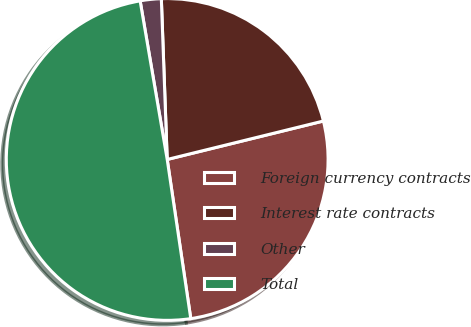<chart> <loc_0><loc_0><loc_500><loc_500><pie_chart><fcel>Foreign currency contracts<fcel>Interest rate contracts<fcel>Other<fcel>Total<nl><fcel>26.5%<fcel>21.74%<fcel>2.11%<fcel>49.65%<nl></chart> 